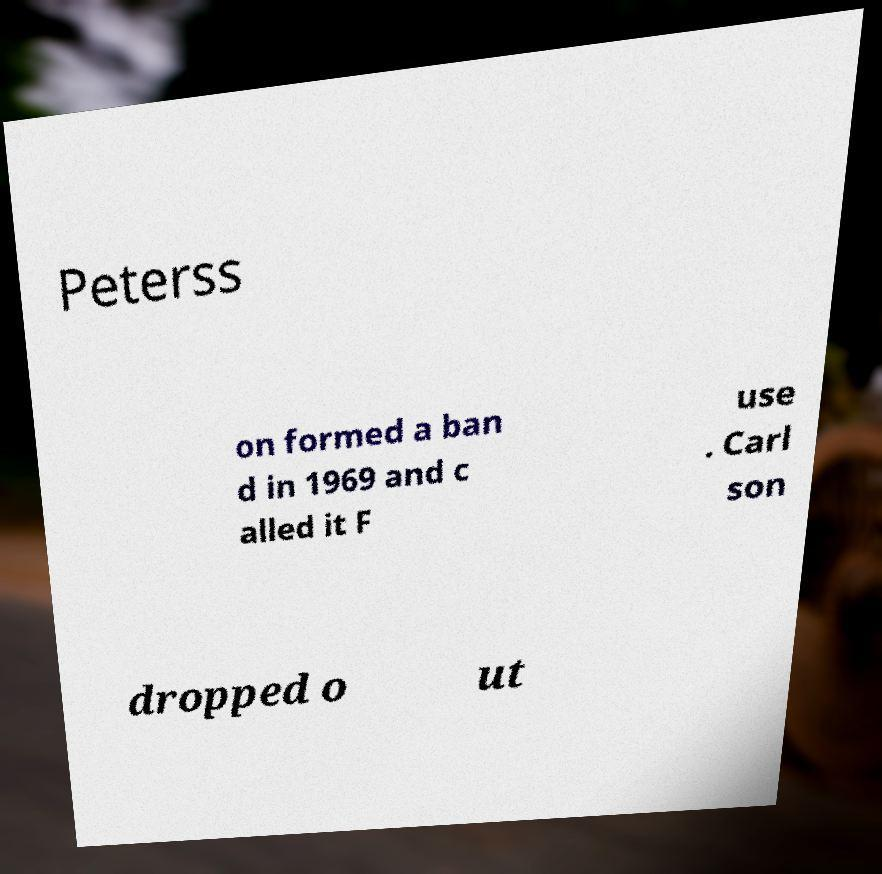I need the written content from this picture converted into text. Can you do that? Peterss on formed a ban d in 1969 and c alled it F use . Carl son dropped o ut 